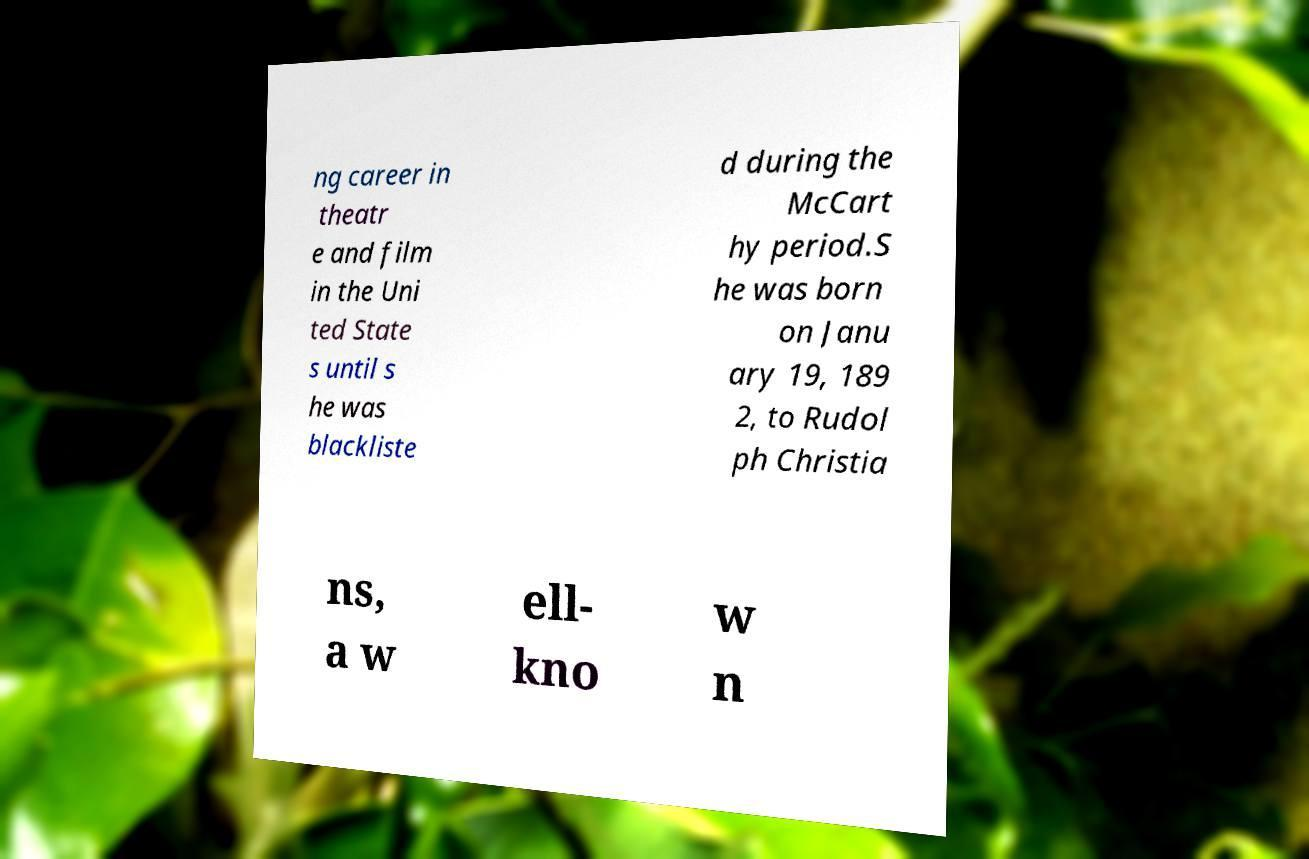Could you extract and type out the text from this image? ng career in theatr e and film in the Uni ted State s until s he was blackliste d during the McCart hy period.S he was born on Janu ary 19, 189 2, to Rudol ph Christia ns, a w ell- kno w n 